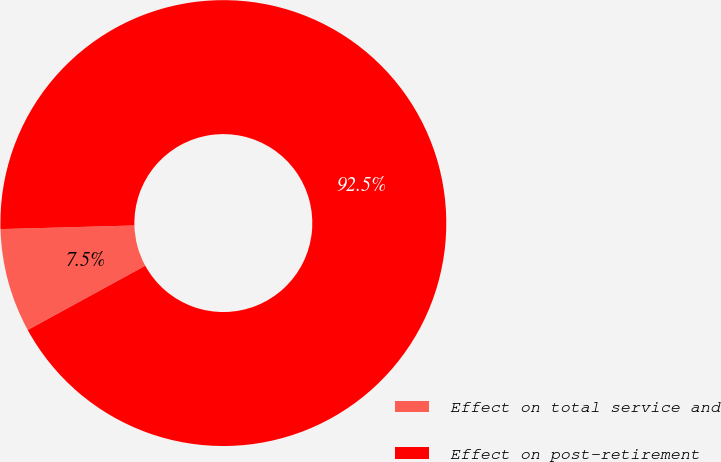Convert chart. <chart><loc_0><loc_0><loc_500><loc_500><pie_chart><fcel>Effect on total service and<fcel>Effect on post-retirement<nl><fcel>7.53%<fcel>92.47%<nl></chart> 